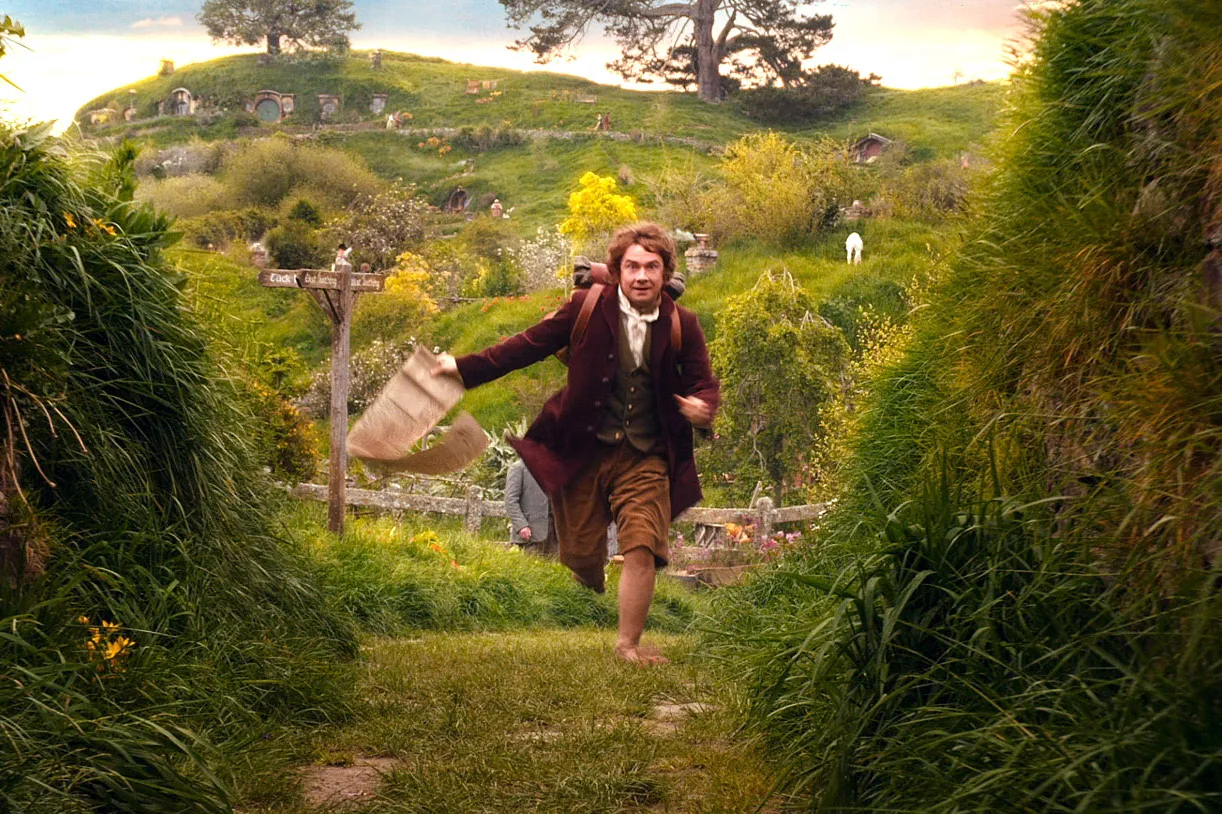What do you think the character is feeling in this moment? The character seems to be experiencing a mix of urgency and determination. The haste in his stride and the focused expression on his face indicate that he is on a crucial mission or an important errand. His destination might hold significant importance, driving his swift movements through the otherwise tranquil Shire. 